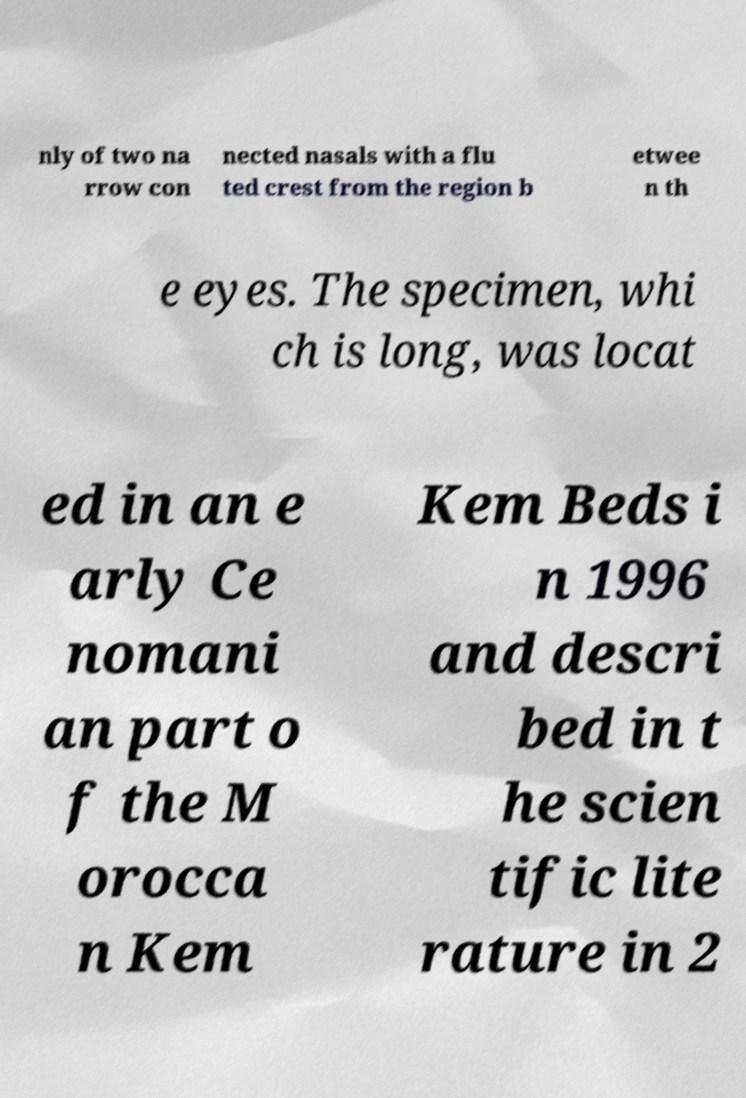There's text embedded in this image that I need extracted. Can you transcribe it verbatim? nly of two na rrow con nected nasals with a flu ted crest from the region b etwee n th e eyes. The specimen, whi ch is long, was locat ed in an e arly Ce nomani an part o f the M orocca n Kem Kem Beds i n 1996 and descri bed in t he scien tific lite rature in 2 